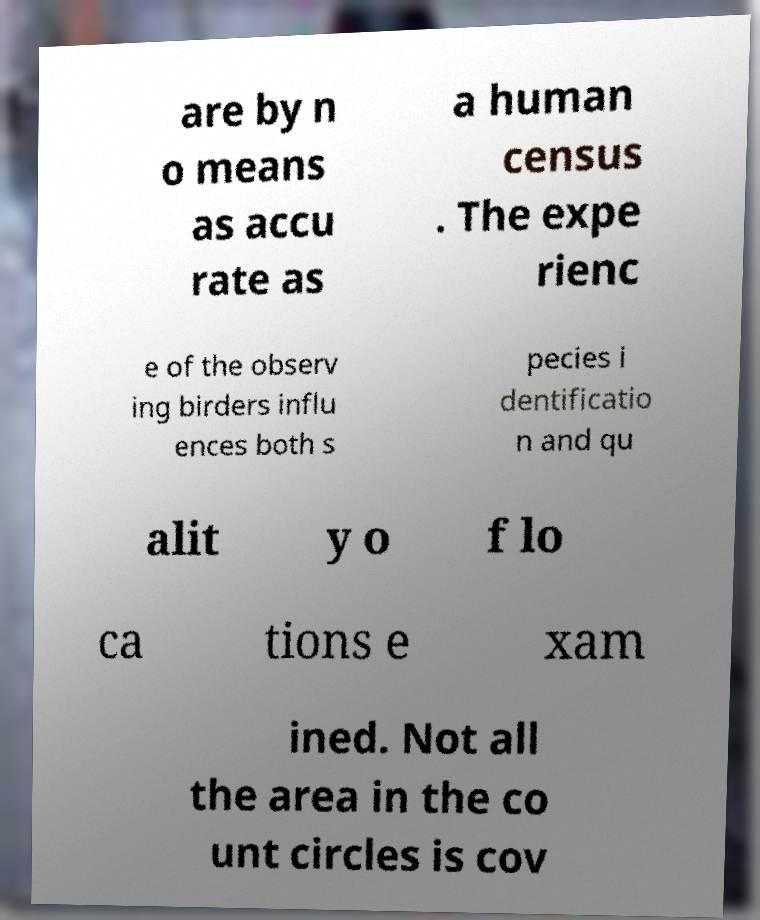What messages or text are displayed in this image? I need them in a readable, typed format. are by n o means as accu rate as a human census . The expe rienc e of the observ ing birders influ ences both s pecies i dentificatio n and qu alit y o f lo ca tions e xam ined. Not all the area in the co unt circles is cov 